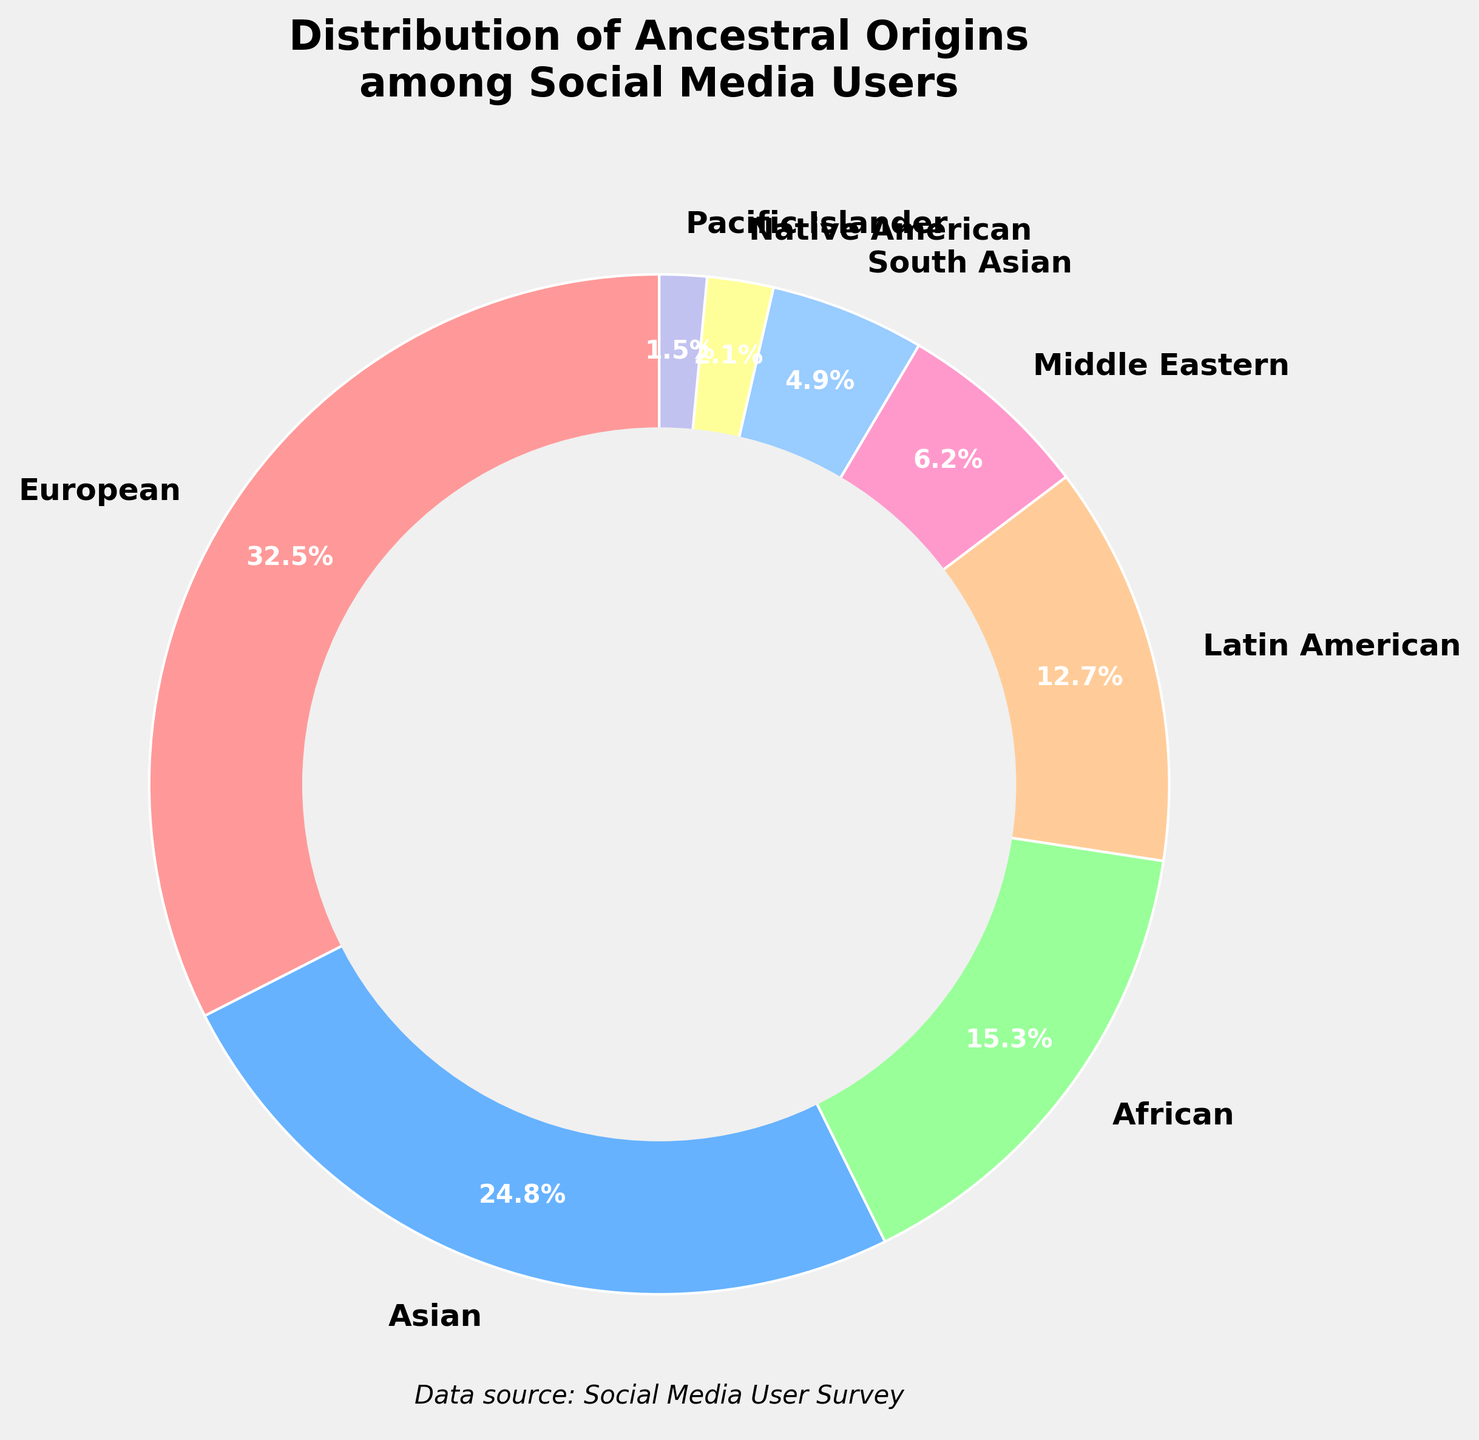What is the most common ancestral origin among social media users? The largest section in the pie chart represents European ancestry, which amounts to 32.5%. This is identified by looking at the percentage labels on the pie chart.
Answer: European, 32.5% How much larger is the percentage of European ancestry compared to Native American ancestry among social media users? European ancestry is 32.5% while Native American ancestry is 2.1%. The difference is computed as 32.5% - 2.1% = 30.4%.
Answer: 30.4% Which two ancestral origins together make up the smallest portion, and what is their combined percentage? The smallest percentages are for Pacific Islander (1.5%) and Native American (2.1%). Their combined percentage is calculated as 1.5% + 2.1% = 3.6%.
Answer: Pacific Islander and Native American, 3.6% Are there more social media users with Asian ancestry or Middle Eastern ancestry? The percentage of Asian ancestry is 24.8% and Middle Eastern ancestry is 6.2%. Since 24.8% is greater than 6.2%, there are more social media users with Asian ancestry.
Answer: Asian Which color represents the African ancestry group in the pie chart? The segment corresponding to African ancestry is 15.3%, which is represented by a green color in the pie chart.
Answer: Green Calculate the combined percentage of social media users with Latin American, South Asian, and Native American ancestry. Latin American is 12.7%, South Asian is 4.9%, and Native American is 2.1%. Their combined percentage is 12.7% + 4.9% + 2.1% = 19.7%.
Answer: 19.7% Of the ancestries listed, which one shows the smallest percentage, and what is that percentage? The smallest percentage shown in the pie chart is for Pacific Islander ancestry at 1.5%.
Answer: Pacific Islander, 1.5% How does the percentage of Latin American ancestry compare with South Asian ancestry among social media users? Latin American ancestry is 12.7%, whereas South Asian ancestry is 4.9%. Therefore, Latin American ancestry is larger.
Answer: Latin American What is the percentage difference between the two most significant ancestry groups? The two most significant groups are European (32.5%) and Asian (24.8%). The percentage difference is 32.5% - 24.8% = 7.7%.
Answer: 7.7% What combined percentage do all ancestries except European and Asian make up? All other ancestries are: African (15.3%), Latin American (12.7%), Middle Eastern (6.2%), South Asian (4.9%), Native American (2.1%), and Pacific Islander (1.5%). Their combined percentage is 15.3% + 12.7% + 6.2% + 4.9% + 2.1% + 1.5% = 42.7%.
Answer: 42.7% 